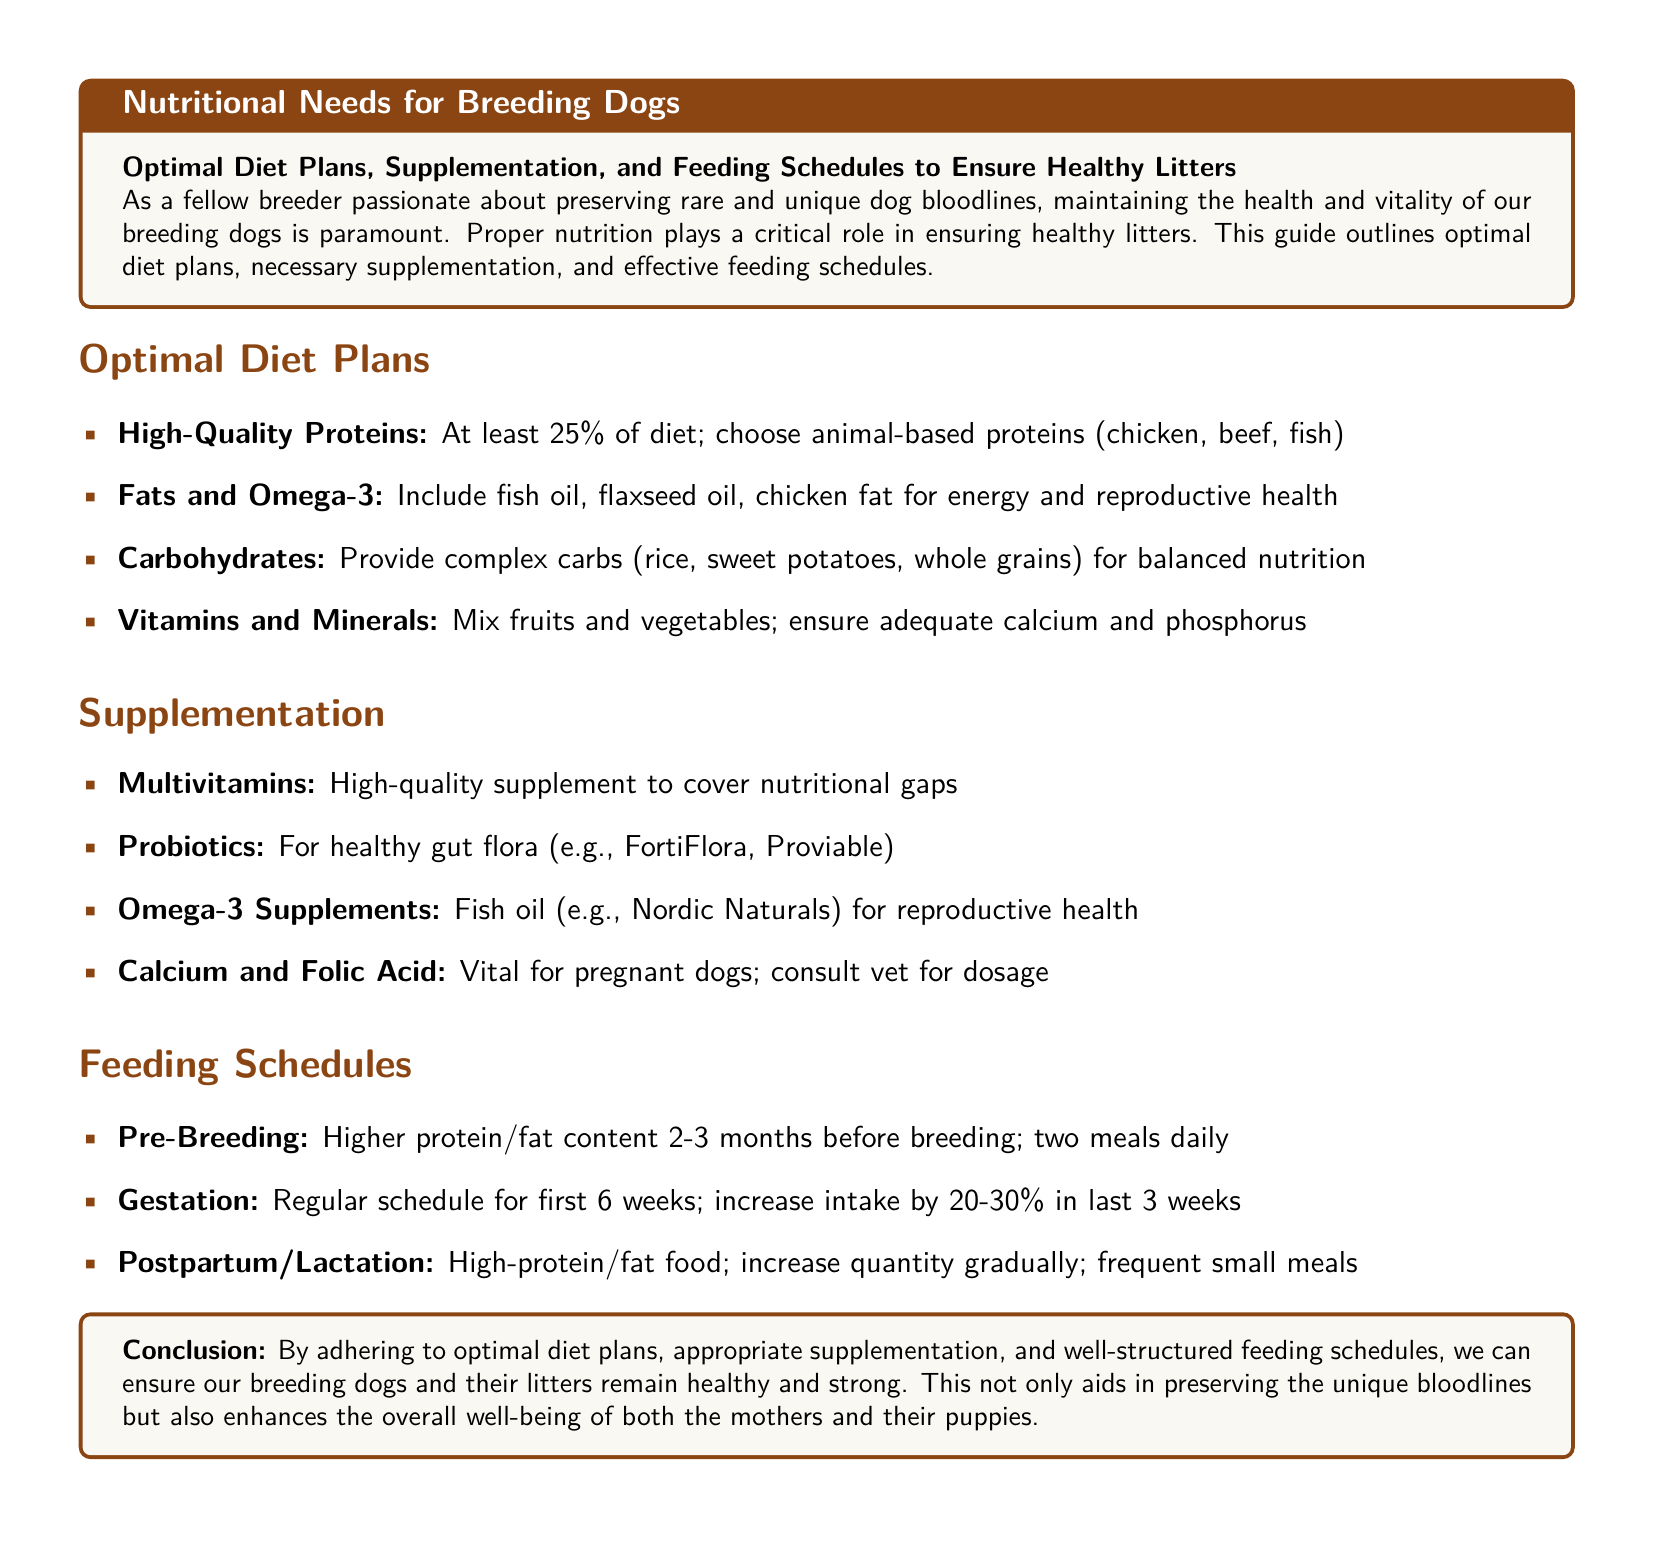What is the minimum percentage of high-quality proteins recommended in the diet? The document states that at least 25% of the diet should consist of high-quality proteins.
Answer: 25% What types of fats should be included for energy and reproductive health? The document mentions fish oil, flaxseed oil, and chicken fat as sources of fat and Omega-3.
Answer: Fish oil, flaxseed oil, chicken fat What are two examples of probiotics mentioned in the guide? It specifically lists FortiFlora and Proviable as examples of probiotics.
Answer: FortiFlora, Proviable How much should the intake increase by in the last three weeks of gestation? The guideline specifies an increase of 20-30% intake during this period.
Answer: 20-30% What type of carbohydrates are recommended for balanced nutrition? The document instructs to provide complex carbohydrates like rice, sweet potatoes, and whole grains.
Answer: Complex carbohydrates What should the feeding schedule include during the postpartum period? The guide recommends high-protein/fat food with frequent small meals during lactation.
Answer: High-protein/fat food; frequent small meals What is a key reason for including calcium and folic acid in supplementation? The document explains that calcium and folic acid are vital for pregnant dogs.
Answer: Vital for pregnant dogs What is the document’s primary focus? The main purpose of the document is to offer guidance on optimal diet plans and supplementation for breeding dogs.
Answer: Nutritional needs for breeding dogs 